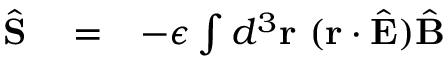<formula> <loc_0><loc_0><loc_500><loc_500>\begin{array} { r l r } { \hat { S } } & = } & { - \epsilon \int d ^ { 3 } { r } \ ( { r } \cdot \hat { E } ) \hat { B } } \end{array}</formula> 